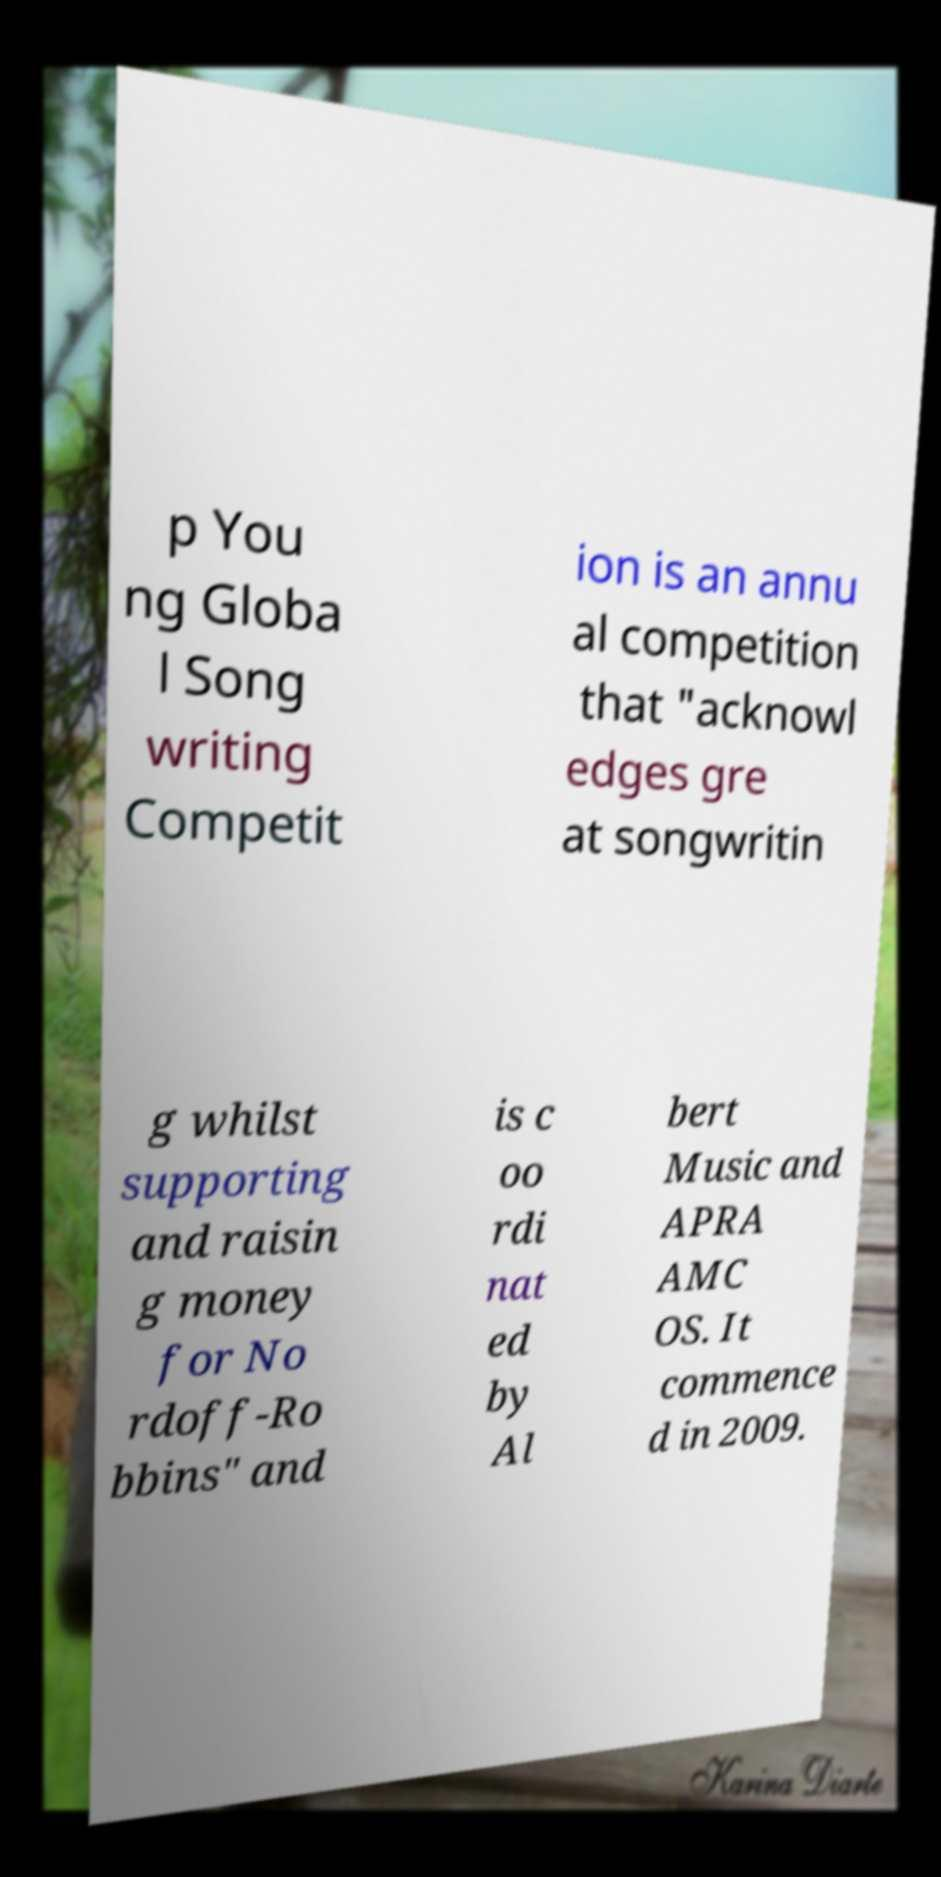Could you assist in decoding the text presented in this image and type it out clearly? p You ng Globa l Song writing Competit ion is an annu al competition that "acknowl edges gre at songwritin g whilst supporting and raisin g money for No rdoff-Ro bbins" and is c oo rdi nat ed by Al bert Music and APRA AMC OS. It commence d in 2009. 